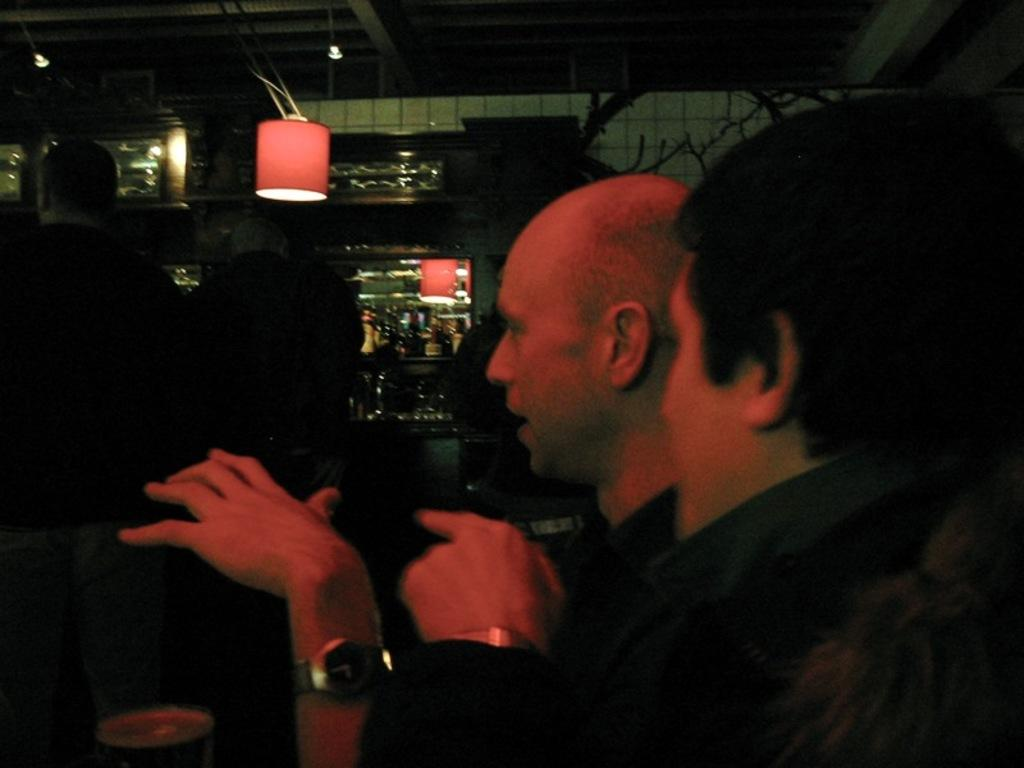Who or what is present in the image? There are people in the image. What can be seen in the center of the image? There are lights in the center of the image. What objects are visible in the background of the image? There are bottles in the background of the image. How would you describe the lighting in the image? The image appears to be slightly dark. Where is the shelf located in the image? There is no shelf present in the image. 